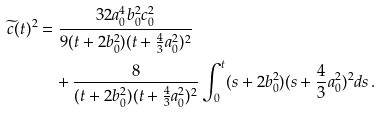Convert formula to latex. <formula><loc_0><loc_0><loc_500><loc_500>\widetilde { c } ( t ) ^ { 2 } & = \frac { 3 2 a _ { 0 } ^ { 4 } b _ { 0 } ^ { 2 } c _ { 0 } ^ { 2 } } { 9 ( t + 2 b _ { 0 } ^ { 2 } ) ( t + \frac { 4 } { 3 } a _ { 0 } ^ { 2 } ) ^ { 2 } } \\ & \quad + \frac { 8 } { ( t + 2 b _ { 0 } ^ { 2 } ) ( t + \frac { 4 } { 3 } a _ { 0 } ^ { 2 } ) ^ { 2 } } \int _ { 0 } ^ { t } ( s + 2 b _ { 0 } ^ { 2 } ) ( s + \frac { 4 } { 3 } a _ { 0 } ^ { 2 } ) ^ { 2 } d s \, . \\</formula> 